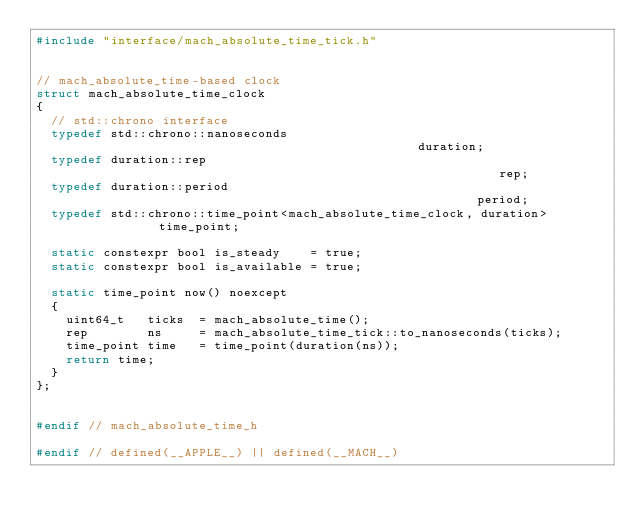<code> <loc_0><loc_0><loc_500><loc_500><_C_>#include "interface/mach_absolute_time_tick.h"


// mach_absolute_time-based clock
struct mach_absolute_time_clock
{
  // std::chrono interface
  typedef std::chrono::nanoseconds                                              duration;
  typedef duration::rep                                                         rep;
  typedef duration::period                                                      period;
  typedef std::chrono::time_point<mach_absolute_time_clock, duration>           time_point;

  static constexpr bool is_steady    = true;
  static constexpr bool is_available = true;

  static time_point now() noexcept
  {
    uint64_t   ticks  = mach_absolute_time();
    rep        ns     = mach_absolute_time_tick::to_nanoseconds(ticks);
    time_point time   = time_point(duration(ns));
    return time;
  }
};


#endif // mach_absolute_time_h

#endif // defined(__APPLE__) || defined(__MACH__)
</code> 